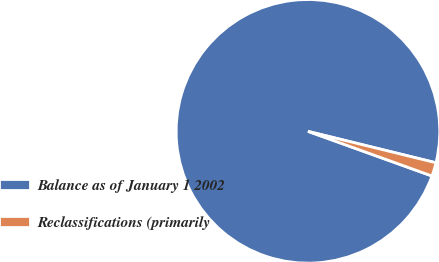<chart> <loc_0><loc_0><loc_500><loc_500><pie_chart><fcel>Balance as of January 1 2002<fcel>Reclassifications (primarily<nl><fcel>98.33%<fcel>1.67%<nl></chart> 